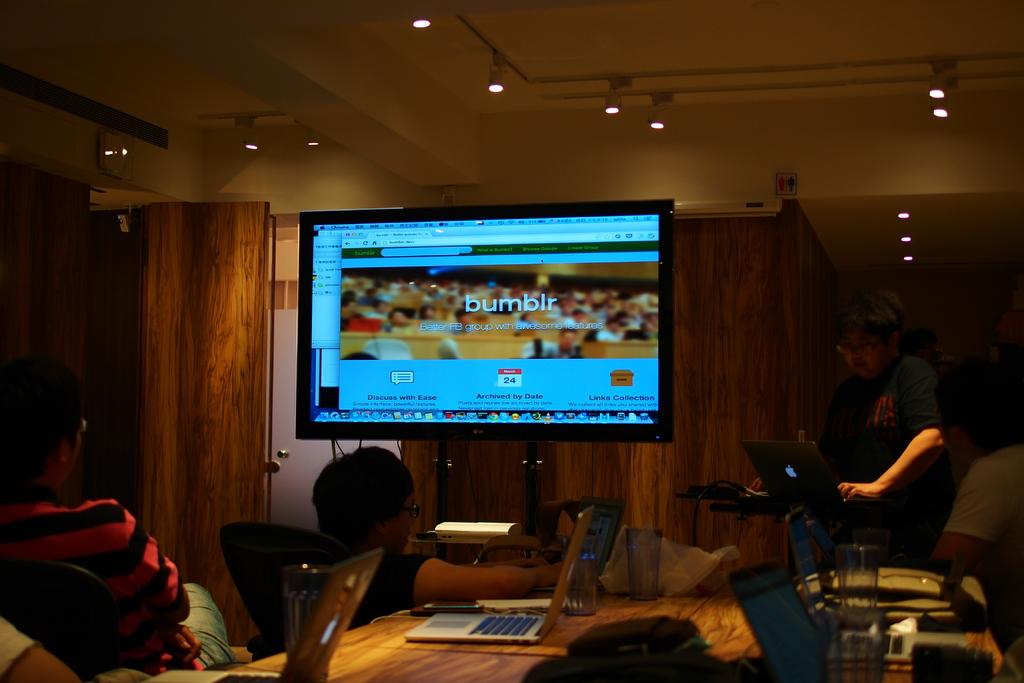What website is seen?
Offer a very short reply. Bumblr. What number or date is shown on the web page?
Your response must be concise. 24. 